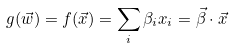<formula> <loc_0><loc_0><loc_500><loc_500>g ( \vec { w } ) = f ( \vec { x } ) = \sum _ { i } \beta _ { i } x _ { i } = \vec { \beta } \cdot \vec { x }</formula> 